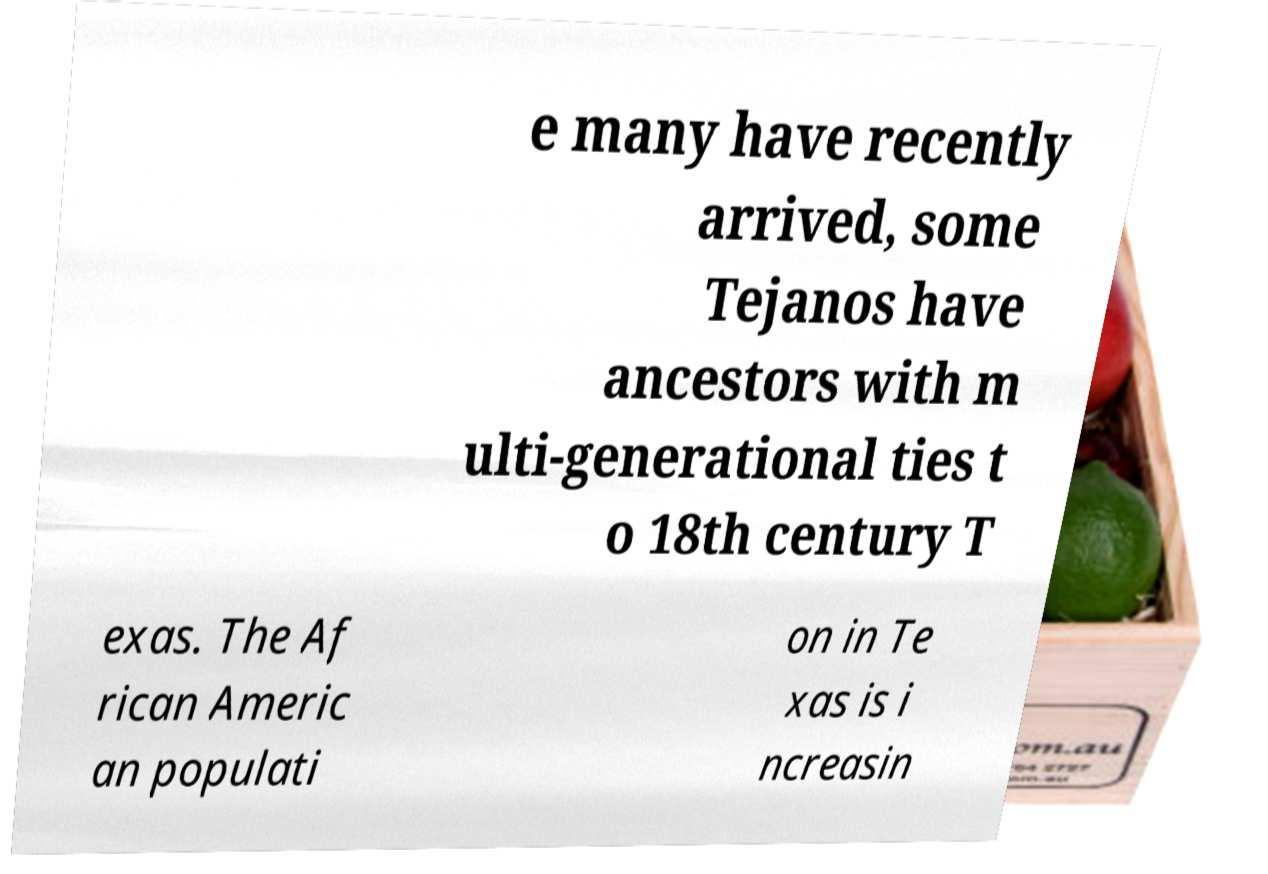There's text embedded in this image that I need extracted. Can you transcribe it verbatim? e many have recently arrived, some Tejanos have ancestors with m ulti-generational ties t o 18th century T exas. The Af rican Americ an populati on in Te xas is i ncreasin 